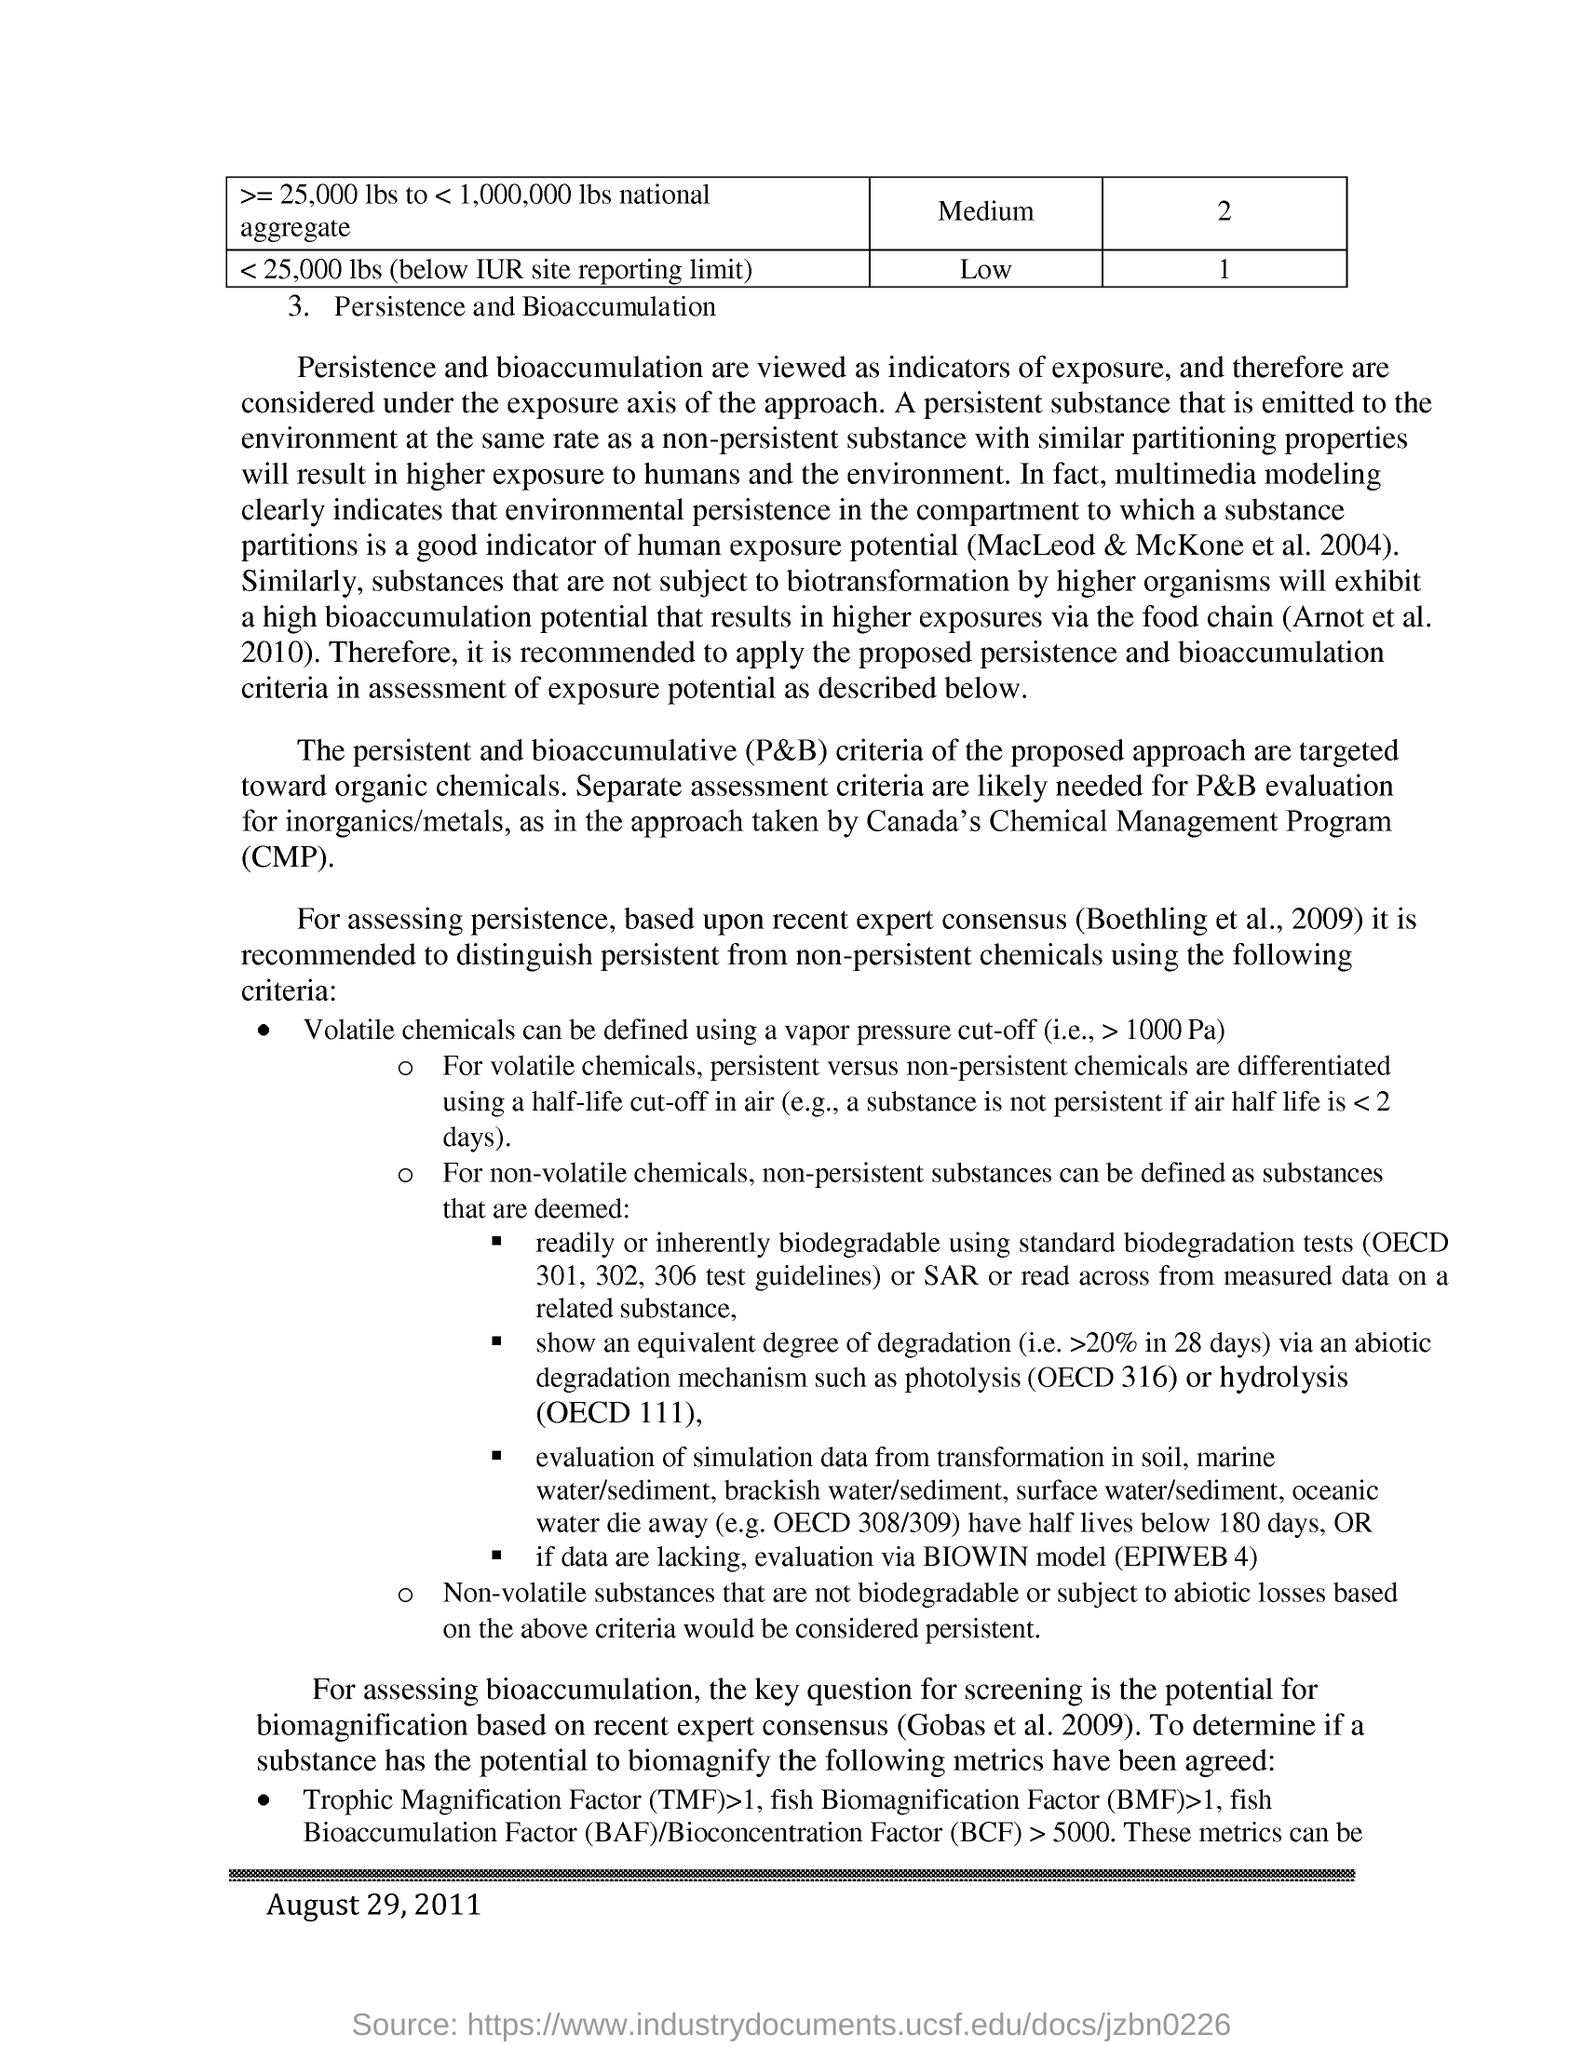Mention a couple of crucial points in this snapshot. Exposure is commonly measured through indicators such as persistence and bioaccumulation. Chemical Management Program, commonly referred to as CMP, is a comprehensive approach to managing chemicals in a responsible and sustainable manner. The criteria proposed for the approach are directed towards organic chemicals. A vapor pressure cut-off can be used to define volatile chemicals. The acronym "TMF" stands for "trophic magnification factor. 